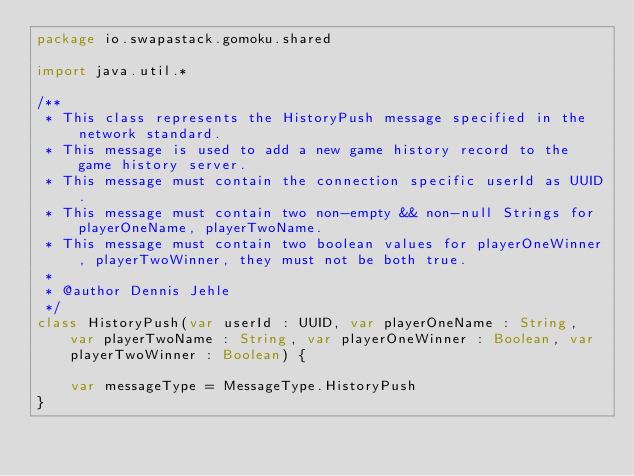<code> <loc_0><loc_0><loc_500><loc_500><_Kotlin_>package io.swapastack.gomoku.shared

import java.util.*

/**
 * This class represents the HistoryPush message specified in the network standard.
 * This message is used to add a new game history record to the game history server.
 * This message must contain the connection specific userId as UUID.
 * This message must contain two non-empty && non-null Strings for playerOneName, playerTwoName.
 * This message must contain two boolean values for playerOneWinner, playerTwoWinner, they must not be both true.
 *
 * @author Dennis Jehle
 */
class HistoryPush(var userId : UUID, var playerOneName : String, var playerTwoName : String, var playerOneWinner : Boolean, var playerTwoWinner : Boolean) {

    var messageType = MessageType.HistoryPush
}</code> 